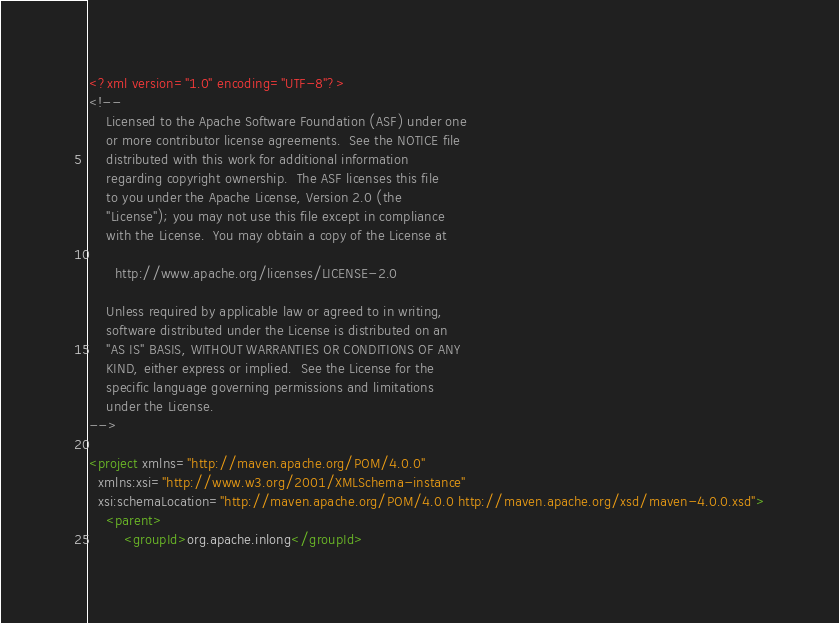Convert code to text. <code><loc_0><loc_0><loc_500><loc_500><_XML_><?xml version="1.0" encoding="UTF-8"?>
<!--
    Licensed to the Apache Software Foundation (ASF) under one
    or more contributor license agreements.  See the NOTICE file
    distributed with this work for additional information
    regarding copyright ownership.  The ASF licenses this file
    to you under the Apache License, Version 2.0 (the
    "License"); you may not use this file except in compliance
    with the License.  You may obtain a copy of the License at

      http://www.apache.org/licenses/LICENSE-2.0

    Unless required by applicable law or agreed to in writing,
    software distributed under the License is distributed on an
    "AS IS" BASIS, WITHOUT WARRANTIES OR CONDITIONS OF ANY
    KIND, either express or implied.  See the License for the
    specific language governing permissions and limitations
    under the License.
-->

<project xmlns="http://maven.apache.org/POM/4.0.0"
  xmlns:xsi="http://www.w3.org/2001/XMLSchema-instance"
  xsi:schemaLocation="http://maven.apache.org/POM/4.0.0 http://maven.apache.org/xsd/maven-4.0.0.xsd">
    <parent>
        <groupId>org.apache.inlong</groupId></code> 